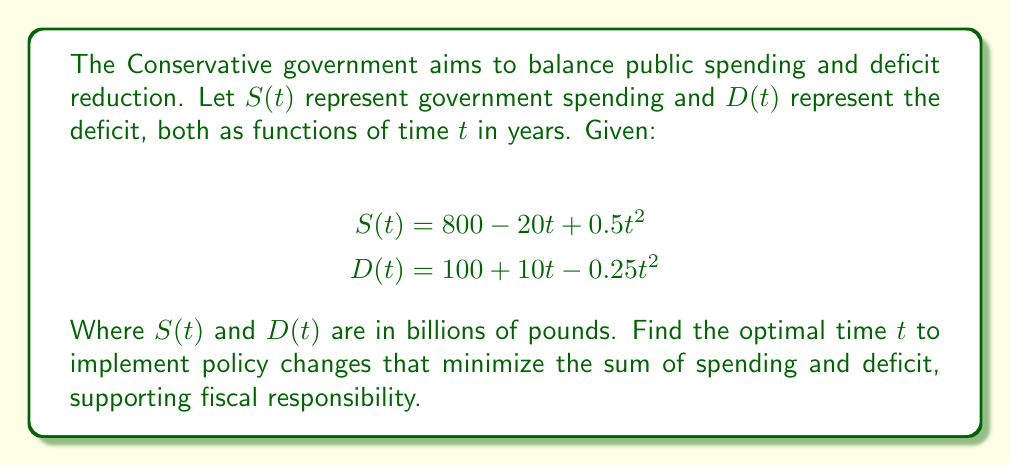Help me with this question. To find the optimal time $t$, we need to minimize the sum of spending and deficit. Let's call this sum $F(t)$:

1) Define the function to minimize:
   $$F(t) = S(t) + D(t) = (800 - 20t + 0.5t^2) + (100 + 10t - 0.25t^2)$$
   $$F(t) = 900 - 10t + 0.25t^2$$

2) To find the minimum, we differentiate $F(t)$ and set it to zero:
   $$F'(t) = -10 + 0.5t$$

3) Set $F'(t) = 0$ and solve for $t$:
   $$-10 + 0.5t = 0$$
   $$0.5t = 10$$
   $$t = 20$$

4) To confirm this is a minimum, check the second derivative:
   $$F''(t) = 0.5 > 0$$
   Since $F''(t)$ is positive, the critical point is a minimum.

5) Therefore, the optimal time to implement policy changes is 20 years from now.

This approach aligns with Conservative principles of fiscal responsibility, balancing long-term deficit reduction with manageable public spending.
Answer: $t = 20$ years 